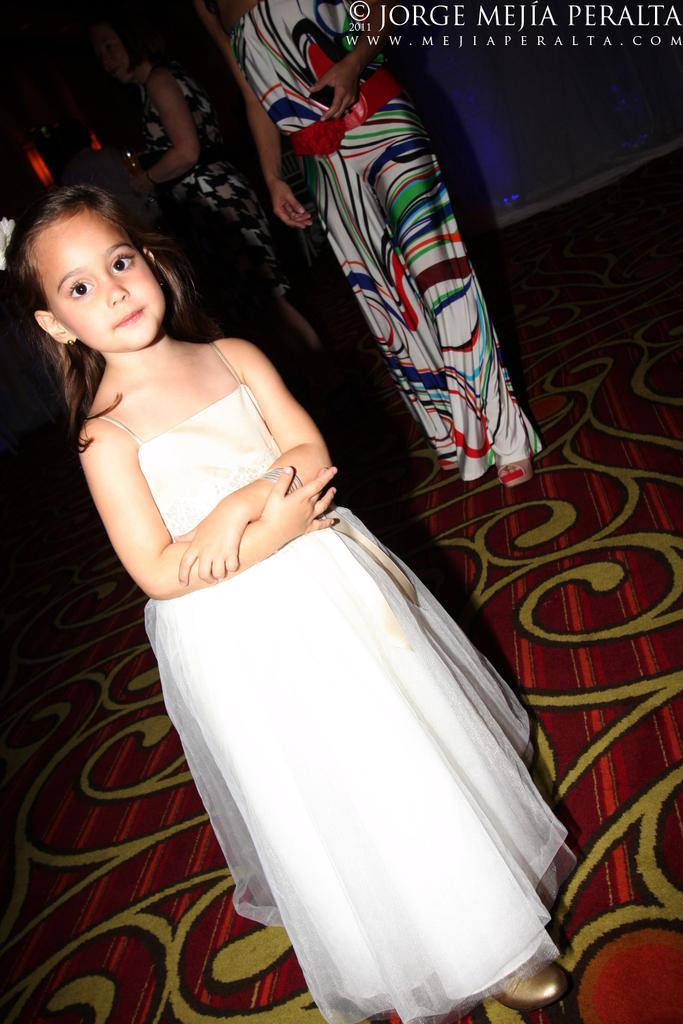In one or two sentences, can you explain what this image depicts? This picture describes about group of people, on the left side of the image we can see a girl, she wore a white color dress, on right top of the image we can see watermarks. 